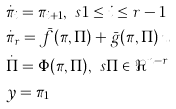Convert formula to latex. <formula><loc_0><loc_0><loc_500><loc_500>& \dot { \pi } _ { i } = \pi _ { i + 1 } , \ s 1 \leq i \leq r - 1 \\ & \dot { \pi } _ { r } = \bar { f } ( \pi , \Pi ) + \bar { g } ( \pi , \Pi ) \, u \\ & \dot { \Pi } = \Phi ( \pi , \Pi ) , \ s \Pi \in \Re ^ { n - r } \\ & y = \pi _ { 1 }</formula> 